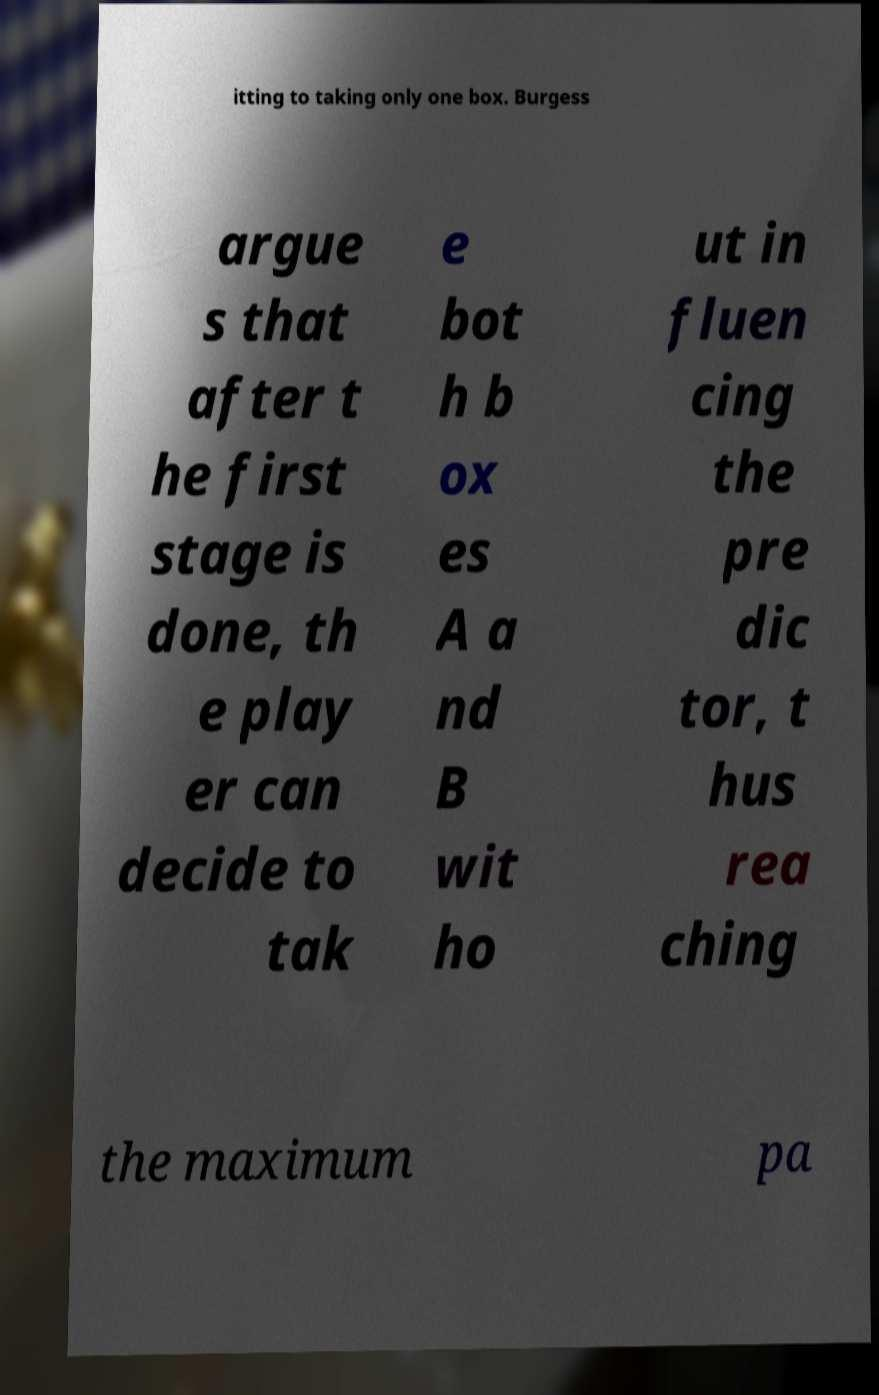Could you assist in decoding the text presented in this image and type it out clearly? itting to taking only one box. Burgess argue s that after t he first stage is done, th e play er can decide to tak e bot h b ox es A a nd B wit ho ut in fluen cing the pre dic tor, t hus rea ching the maximum pa 